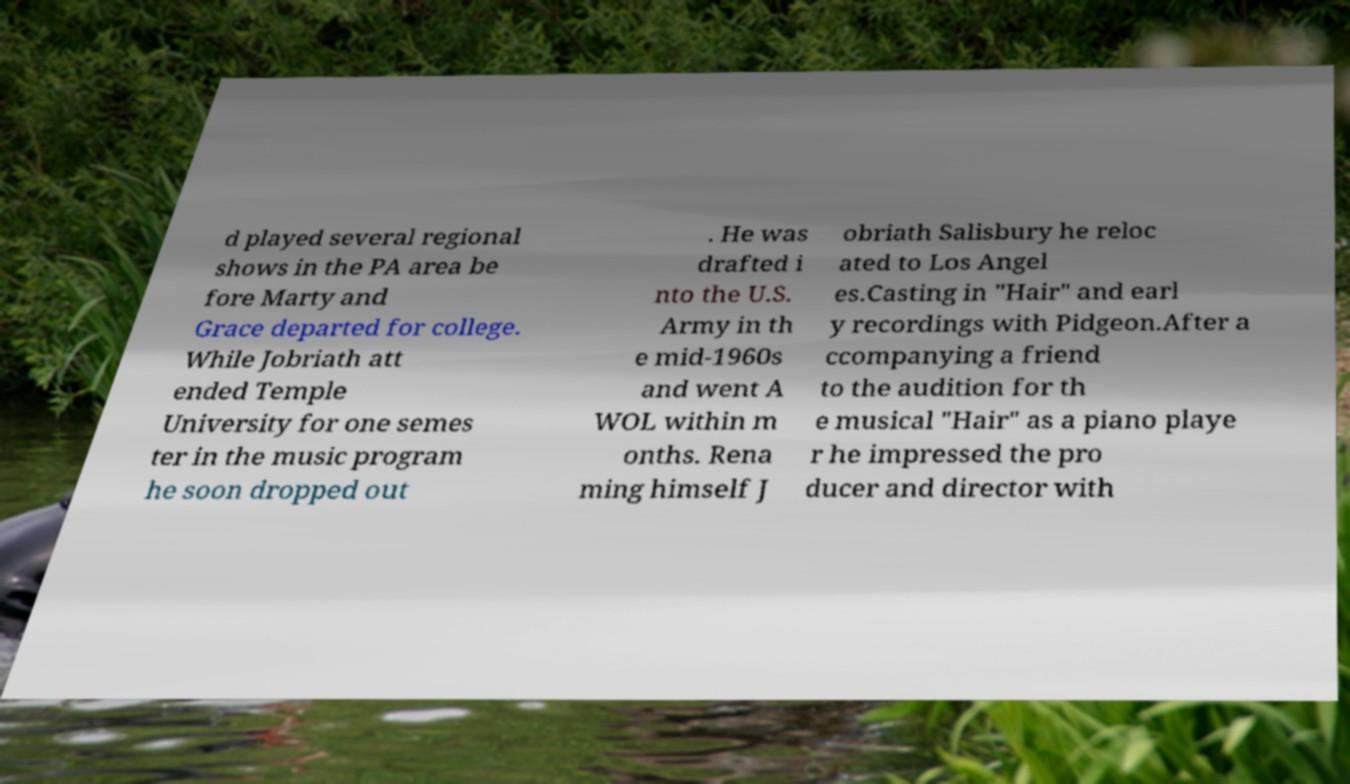Please identify and transcribe the text found in this image. d played several regional shows in the PA area be fore Marty and Grace departed for college. While Jobriath att ended Temple University for one semes ter in the music program he soon dropped out . He was drafted i nto the U.S. Army in th e mid-1960s and went A WOL within m onths. Rena ming himself J obriath Salisbury he reloc ated to Los Angel es.Casting in "Hair" and earl y recordings with Pidgeon.After a ccompanying a friend to the audition for th e musical "Hair" as a piano playe r he impressed the pro ducer and director with 